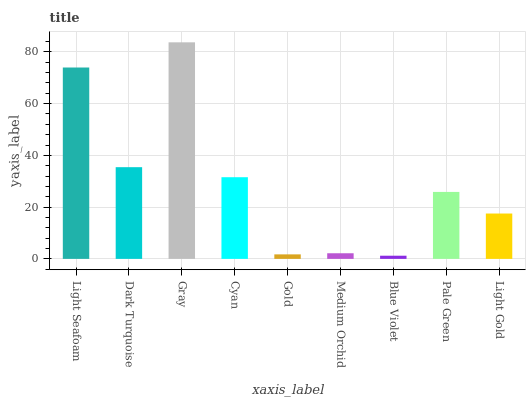Is Blue Violet the minimum?
Answer yes or no. Yes. Is Gray the maximum?
Answer yes or no. Yes. Is Dark Turquoise the minimum?
Answer yes or no. No. Is Dark Turquoise the maximum?
Answer yes or no. No. Is Light Seafoam greater than Dark Turquoise?
Answer yes or no. Yes. Is Dark Turquoise less than Light Seafoam?
Answer yes or no. Yes. Is Dark Turquoise greater than Light Seafoam?
Answer yes or no. No. Is Light Seafoam less than Dark Turquoise?
Answer yes or no. No. Is Pale Green the high median?
Answer yes or no. Yes. Is Pale Green the low median?
Answer yes or no. Yes. Is Gray the high median?
Answer yes or no. No. Is Light Gold the low median?
Answer yes or no. No. 